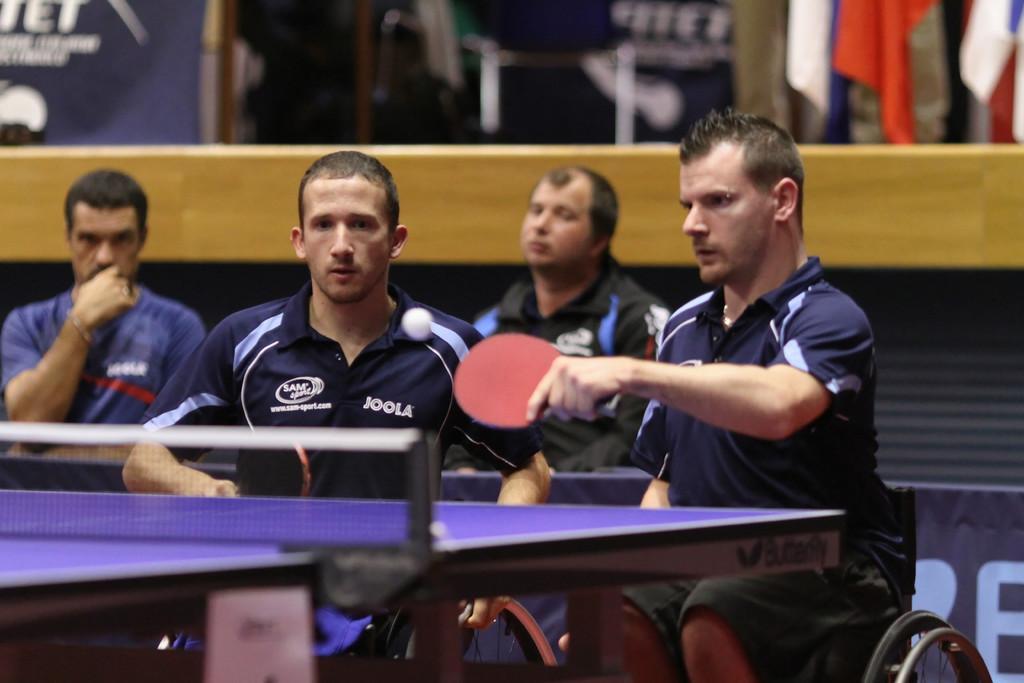In one or two sentences, can you explain what this image depicts? In the picture we can see some people are playing a table tennis and they are in a sports wear and one person sitting on the wheel chair and holding a table tennis bat and behind them we can see a wall with a wooden plank on it, and top of it we can see some things are placed.. 